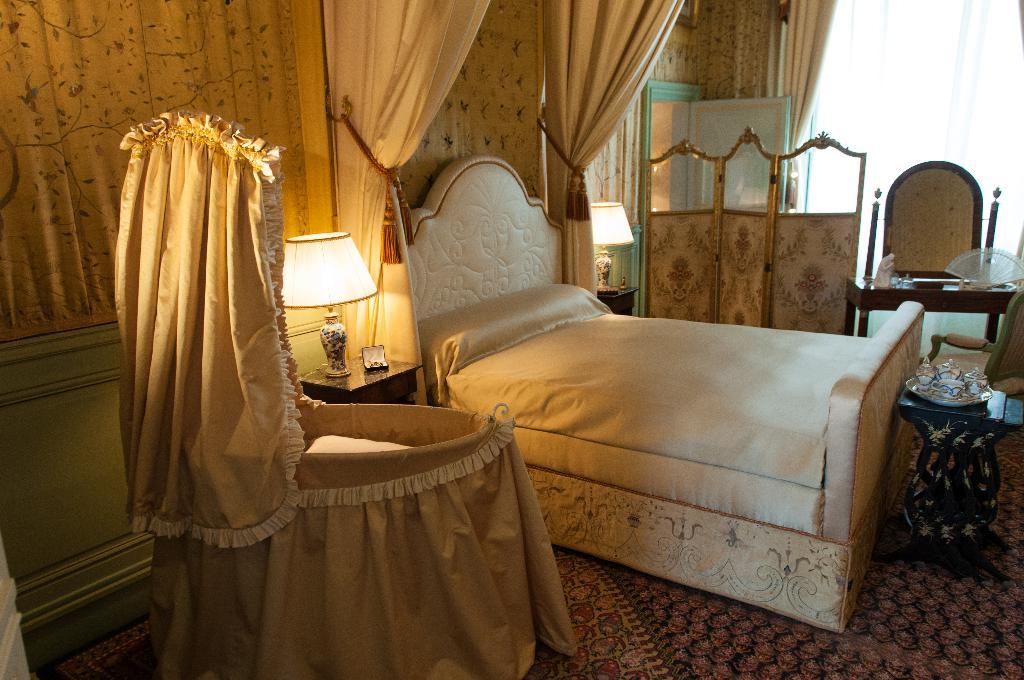What type of window treatment is present in the image? There are curtains in the image. What is the main piece of furniture in the room? There is a bed in the image. What supports the bed? There is a bed frame in the image. What might be used for clothing storage in the image? There are clothes in the image. What type of furniture is present for placing objects on? There are tables in the image. What type of lighting is present in the image? There are bed lamps in the image. What type of floor covering is present in the image? There is a floor carpet in the image. What other objects can be seen in the image? There are additional objects in the image. Can you hear the alarm going off in the image? There is no alarm present in the image, so it cannot be heard. What type of laughter can be heard coming from the bed lamps? There is no laughter present in the image, as bed lamps do not have the ability to laugh. 